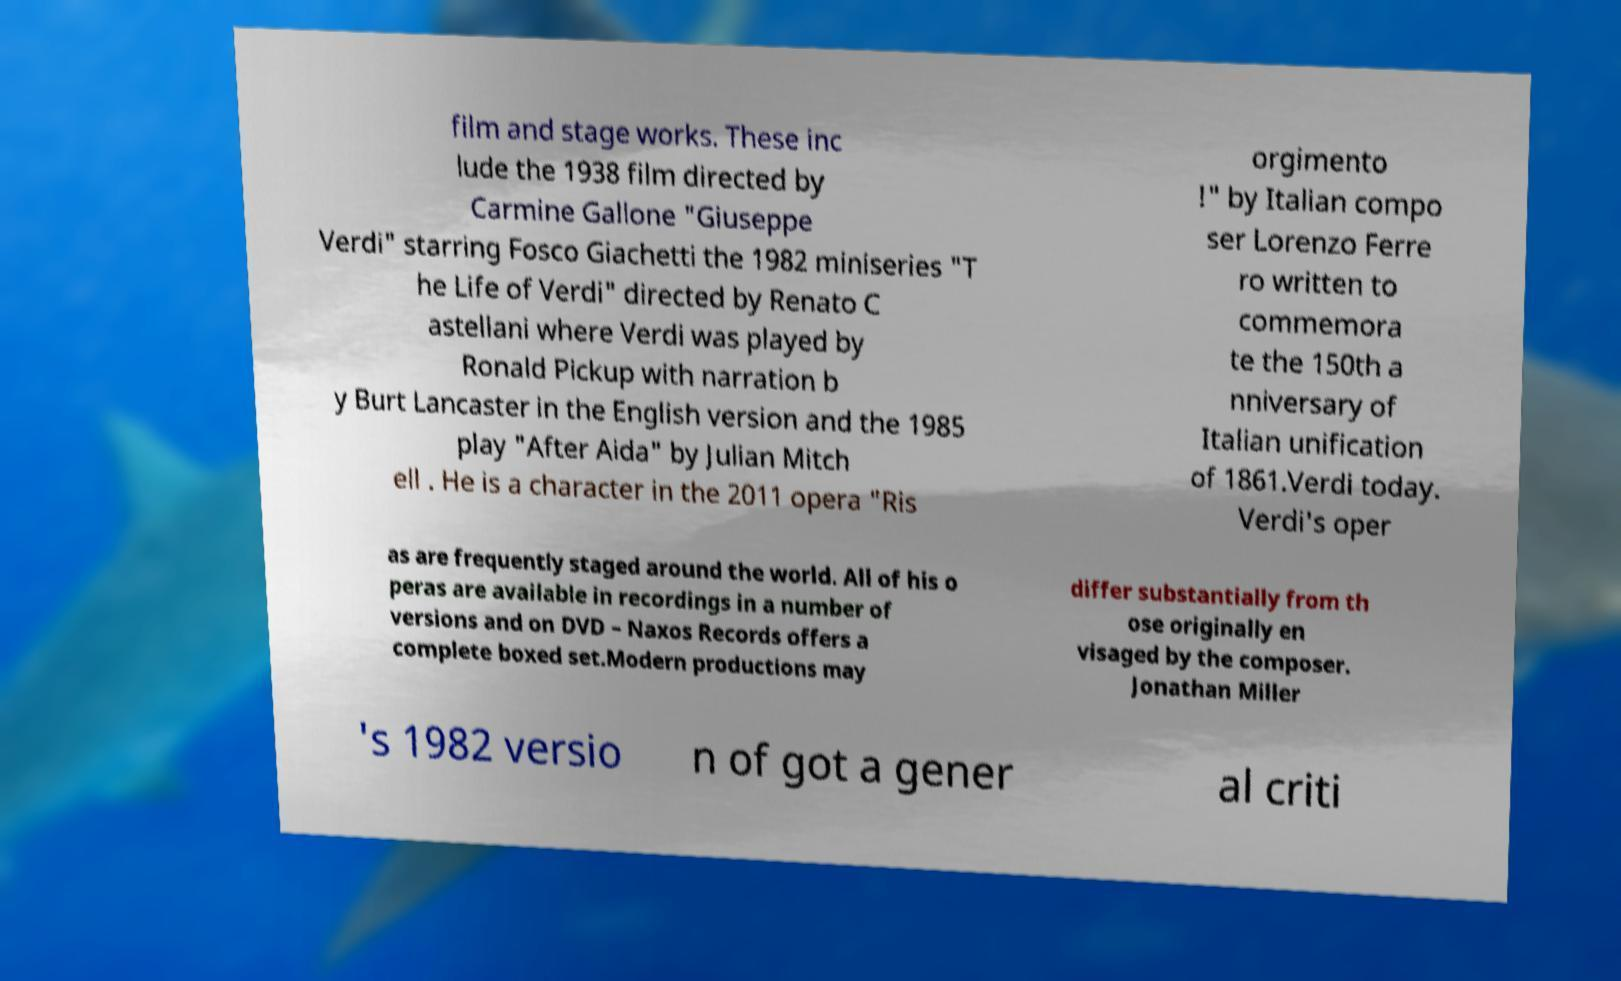There's text embedded in this image that I need extracted. Can you transcribe it verbatim? film and stage works. These inc lude the 1938 film directed by Carmine Gallone "Giuseppe Verdi" starring Fosco Giachetti the 1982 miniseries "T he Life of Verdi" directed by Renato C astellani where Verdi was played by Ronald Pickup with narration b y Burt Lancaster in the English version and the 1985 play "After Aida" by Julian Mitch ell . He is a character in the 2011 opera "Ris orgimento !" by Italian compo ser Lorenzo Ferre ro written to commemora te the 150th a nniversary of Italian unification of 1861.Verdi today. Verdi's oper as are frequently staged around the world. All of his o peras are available in recordings in a number of versions and on DVD – Naxos Records offers a complete boxed set.Modern productions may differ substantially from th ose originally en visaged by the composer. Jonathan Miller 's 1982 versio n of got a gener al criti 